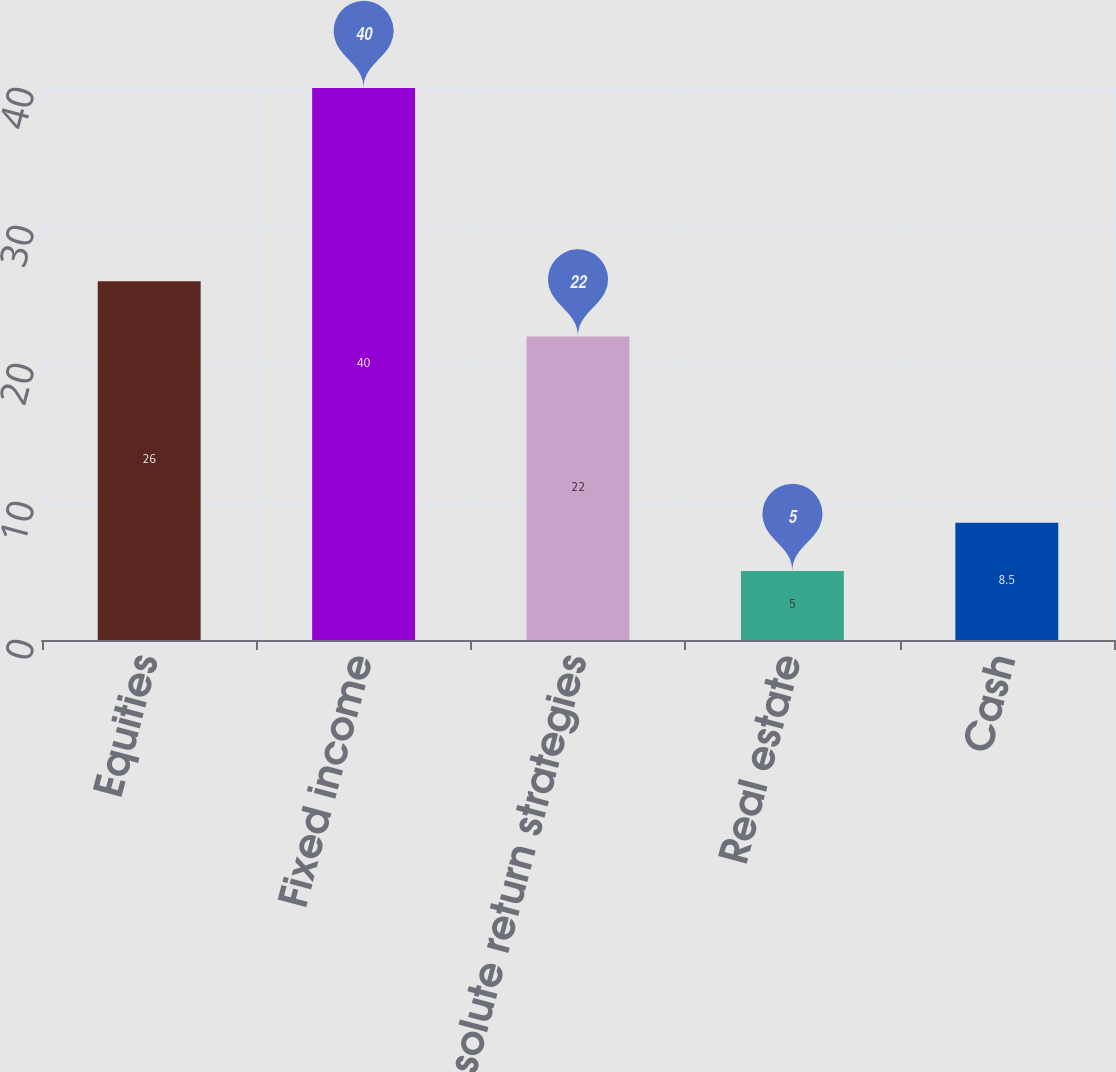<chart> <loc_0><loc_0><loc_500><loc_500><bar_chart><fcel>Equities<fcel>Fixed income<fcel>Absolute return strategies<fcel>Real estate<fcel>Cash<nl><fcel>26<fcel>40<fcel>22<fcel>5<fcel>8.5<nl></chart> 